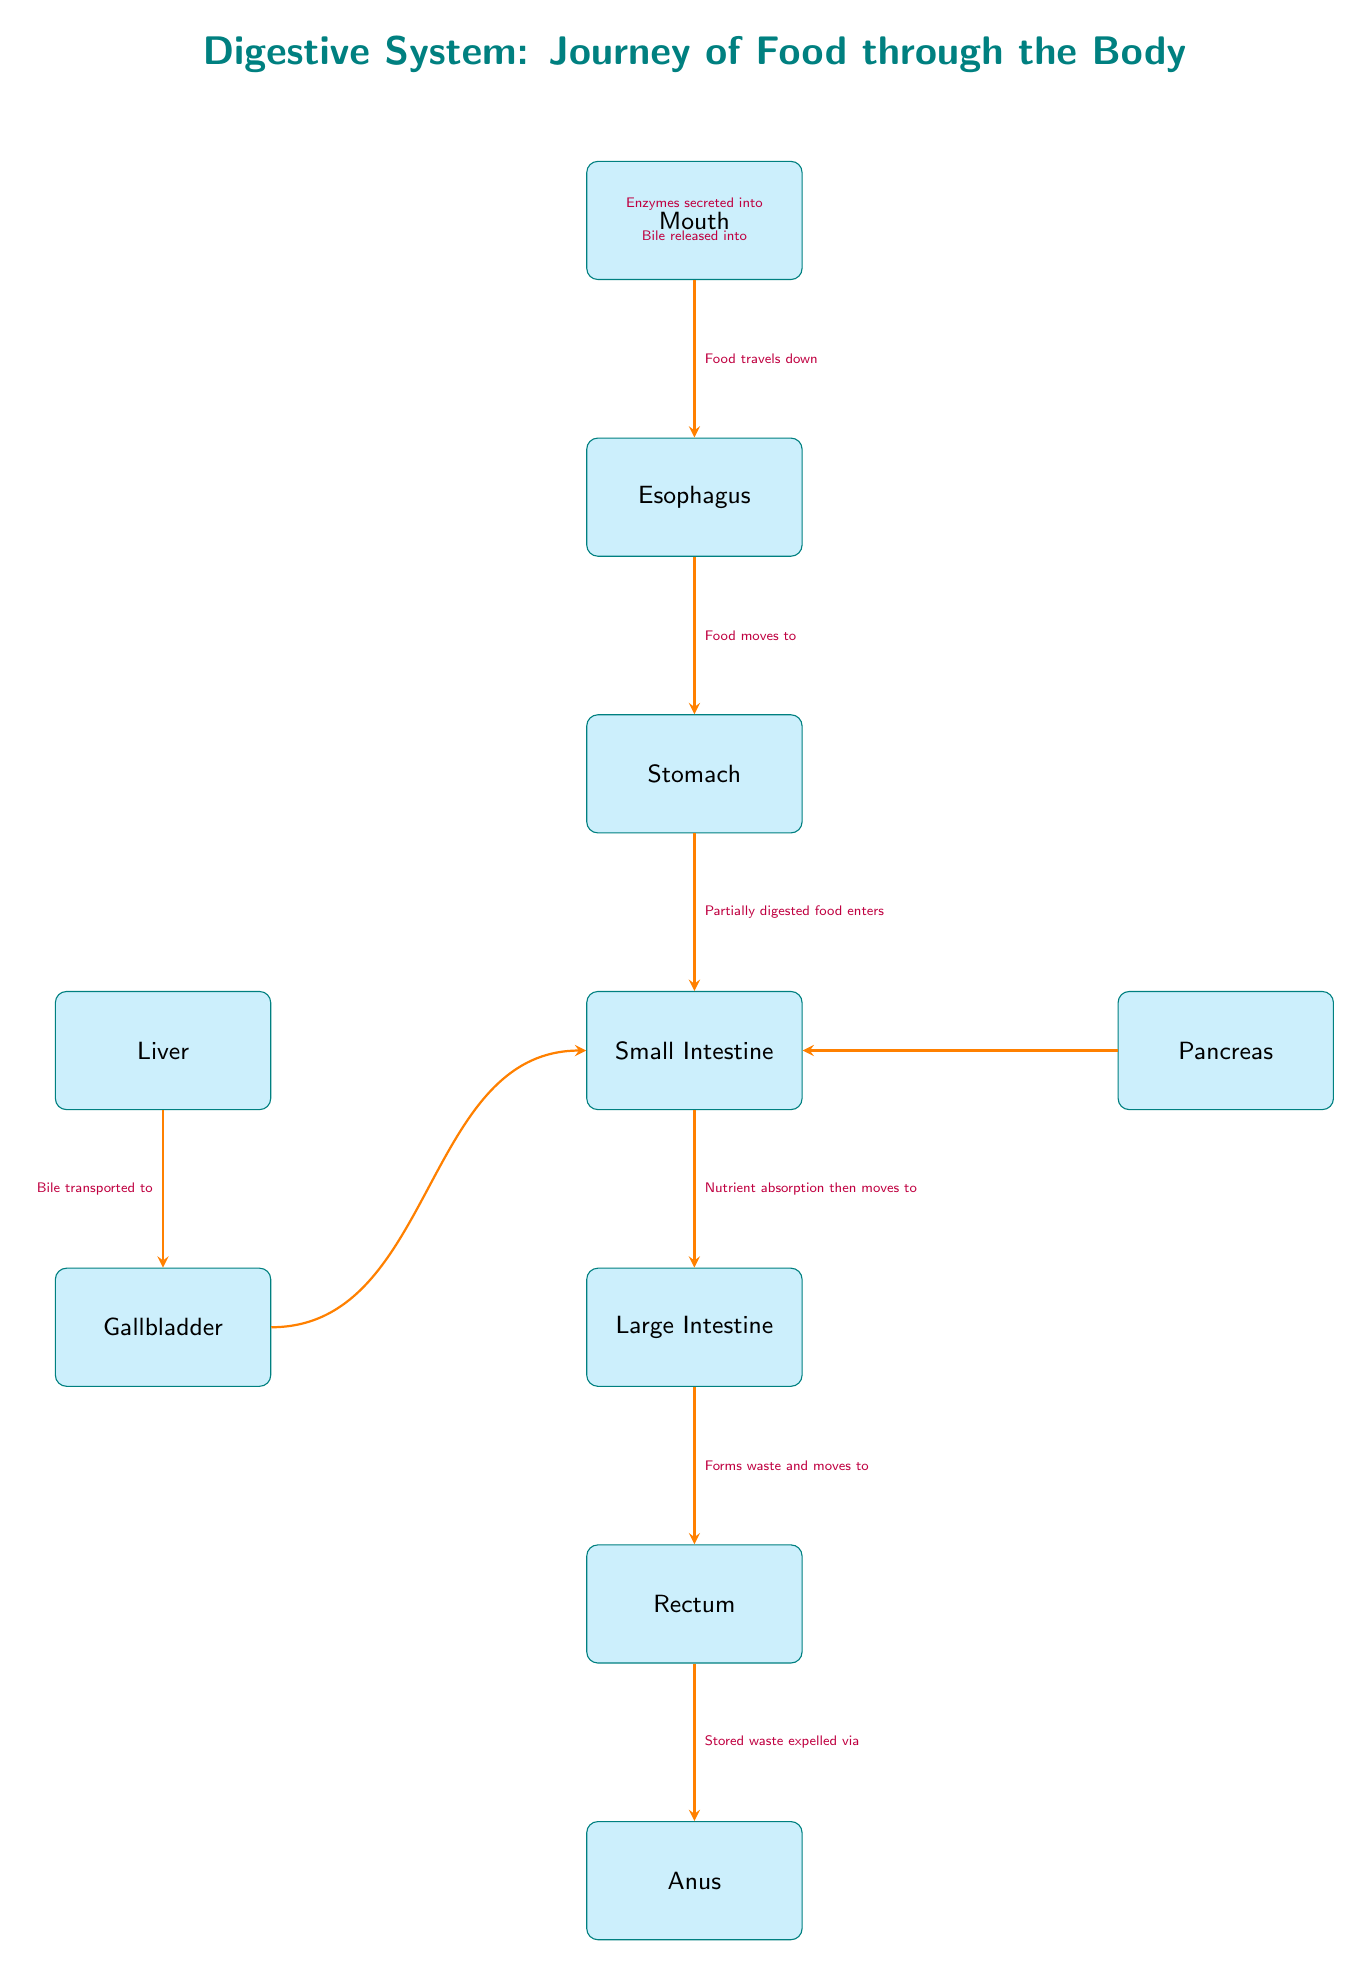What is the first organ in the digestive system according to the diagram? The diagram shows the journey of food starting from the mouth as the first organ listed above the esophagus.
Answer: Mouth How many organs are involved in the digestive process as depicted in the diagram? By counting the organs in the diagram, I see there are a total of six organs listed in a downward order, and there are three additional organs (liver, gallbladder, pancreas) on the sides, making a total of nine.
Answer: Nine What does the liver transport to the gallbladder? The arrow indicates that the liver transports bile to the gallbladder, as specified in the label next to the arrow connecting these two organs.
Answer: Bile Which organ is responsible for nutrient absorption? The small intestine is explicitly mentioned in the diagram as the organ where nutrient absorption occurs, illustrated by the arrow moving from the stomach to the small intestine.
Answer: Small Intestine What happens to waste as it moves through the large intestine? The large intestine's role is to form waste which is indicated in the label of the arrow that leads from the large intestine to the rectum.
Answer: Forms waste In which organ does bile get released into? The diagram indicates that bile is released into the small intestine, as shown in the arrow that originates from the gallbladder.
Answer: Small Intestine From which organ are enzymes secreted into the small intestine? The pancreas is pointed out in the diagram as the organ that secretes enzymes into the small intestine, indicated by the respective arrow.
Answer: Pancreas What is the final step in the journey of food through the digestive system? The final step depicted in the diagram is the waste being expelled via the anus, as shown in the last arrow originating from the rectum.
Answer: Anus How does food travel from the esophagus to the stomach? The label next to the arrow indicates that food moves from the esophagus to the stomach, detailing the movement of food during digestion.
Answer: Food moves to 